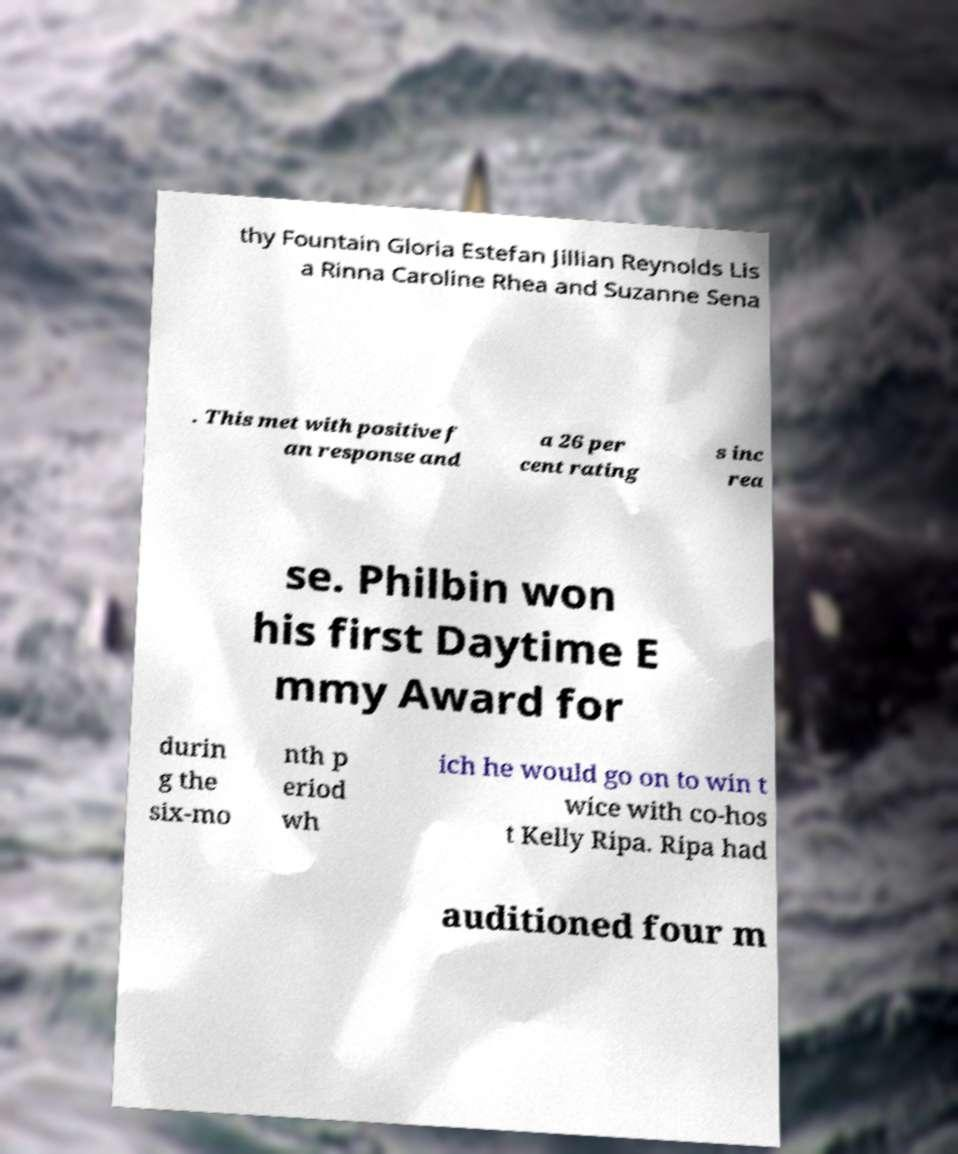Can you accurately transcribe the text from the provided image for me? thy Fountain Gloria Estefan Jillian Reynolds Lis a Rinna Caroline Rhea and Suzanne Sena . This met with positive f an response and a 26 per cent rating s inc rea se. Philbin won his first Daytime E mmy Award for durin g the six-mo nth p eriod wh ich he would go on to win t wice with co-hos t Kelly Ripa. Ripa had auditioned four m 